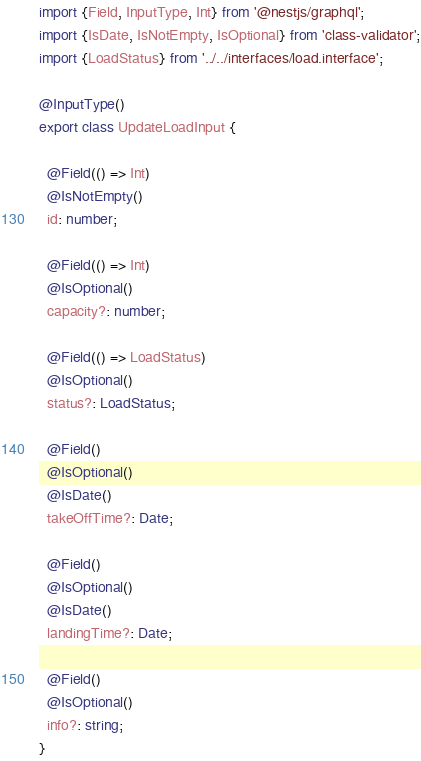<code> <loc_0><loc_0><loc_500><loc_500><_TypeScript_>import {Field, InputType, Int} from '@nestjs/graphql';
import {IsDate, IsNotEmpty, IsOptional} from 'class-validator';
import {LoadStatus} from '../../interfaces/load.interface';

@InputType()
export class UpdateLoadInput {

  @Field(() => Int)
  @IsNotEmpty()
  id: number;

  @Field(() => Int)
  @IsOptional()
  capacity?: number;

  @Field(() => LoadStatus)
  @IsOptional()
  status?: LoadStatus;

  @Field()
  @IsOptional()
  @IsDate()
  takeOffTime?: Date;

  @Field()
  @IsOptional()
  @IsDate()
  landingTime?: Date;

  @Field()
  @IsOptional()
  info?: string;
}
</code> 